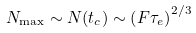Convert formula to latex. <formula><loc_0><loc_0><loc_500><loc_500>N _ { \max } \sim N ( t _ { c } ) \sim \left ( F \tau _ { e } \right ) ^ { 2 / 3 }</formula> 